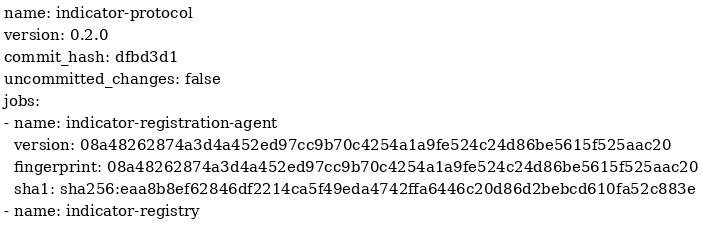Convert code to text. <code><loc_0><loc_0><loc_500><loc_500><_YAML_>name: indicator-protocol
version: 0.2.0
commit_hash: dfbd3d1
uncommitted_changes: false
jobs:
- name: indicator-registration-agent
  version: 08a48262874a3d4a452ed97cc9b70c4254a1a9fe524c24d86be5615f525aac20
  fingerprint: 08a48262874a3d4a452ed97cc9b70c4254a1a9fe524c24d86be5615f525aac20
  sha1: sha256:eaa8b8ef62846df2214ca5f49eda4742ffa6446c20d86d2bebcd610fa52c883e
- name: indicator-registry</code> 